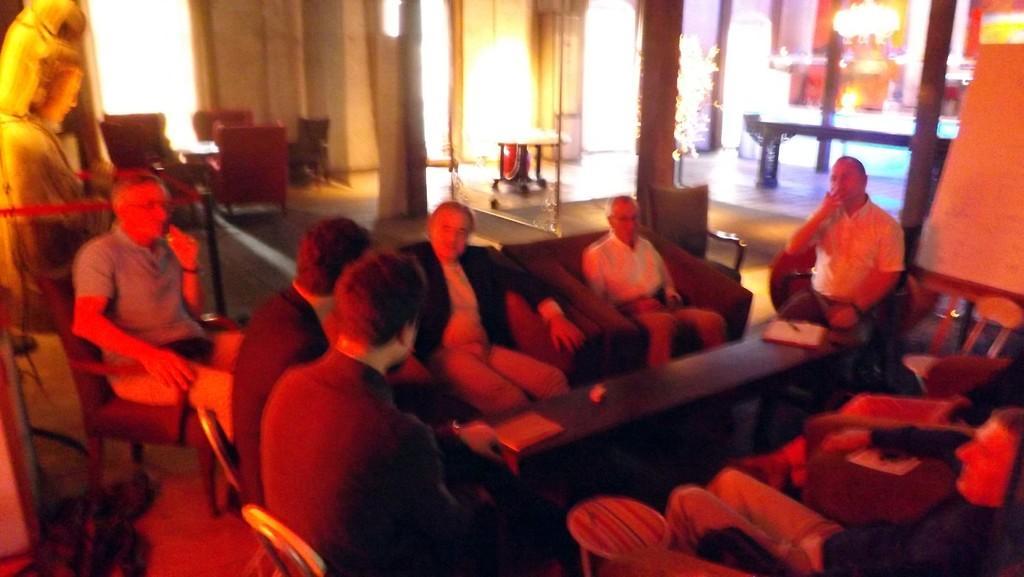Could you give a brief overview of what you see in this image? In this picture I can see many men who are sitting on the couch near to the table. On the table I can see the books and paper. In the back I can see other tables, chairs, lights and windows. In the top right corner there is a chandelier. 